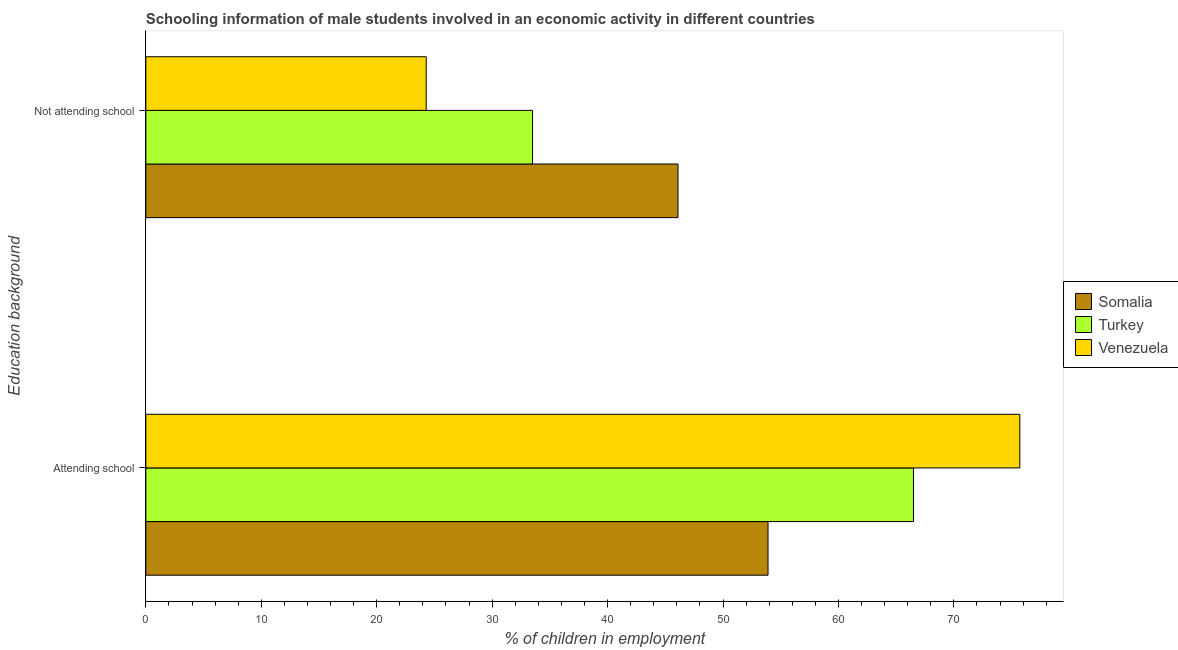How many different coloured bars are there?
Your answer should be compact. 3. How many groups of bars are there?
Your answer should be compact. 2. Are the number of bars on each tick of the Y-axis equal?
Your answer should be very brief. Yes. How many bars are there on the 1st tick from the top?
Your response must be concise. 3. What is the label of the 1st group of bars from the top?
Ensure brevity in your answer.  Not attending school. What is the percentage of employed males who are attending school in Somalia?
Provide a short and direct response. 53.9. Across all countries, what is the maximum percentage of employed males who are not attending school?
Give a very brief answer. 46.1. Across all countries, what is the minimum percentage of employed males who are not attending school?
Your answer should be compact. 24.29. In which country was the percentage of employed males who are not attending school maximum?
Make the answer very short. Somalia. In which country was the percentage of employed males who are not attending school minimum?
Make the answer very short. Venezuela. What is the total percentage of employed males who are not attending school in the graph?
Provide a short and direct response. 103.89. What is the difference between the percentage of employed males who are not attending school in Somalia and that in Turkey?
Your answer should be very brief. 12.6. What is the difference between the percentage of employed males who are not attending school in Somalia and the percentage of employed males who are attending school in Turkey?
Make the answer very short. -20.4. What is the average percentage of employed males who are attending school per country?
Your answer should be compact. 65.37. What is the difference between the percentage of employed males who are attending school and percentage of employed males who are not attending school in Venezuela?
Your answer should be very brief. 51.43. In how many countries, is the percentage of employed males who are not attending school greater than 52 %?
Offer a terse response. 0. What is the ratio of the percentage of employed males who are attending school in Somalia to that in Turkey?
Give a very brief answer. 0.81. Is the percentage of employed males who are attending school in Venezuela less than that in Somalia?
Give a very brief answer. No. What does the 3rd bar from the bottom in Attending school represents?
Provide a short and direct response. Venezuela. How many bars are there?
Provide a succinct answer. 6. How many countries are there in the graph?
Offer a terse response. 3. What is the difference between two consecutive major ticks on the X-axis?
Offer a terse response. 10. Are the values on the major ticks of X-axis written in scientific E-notation?
Offer a very short reply. No. Does the graph contain any zero values?
Your answer should be compact. No. Where does the legend appear in the graph?
Your answer should be very brief. Center right. What is the title of the graph?
Your answer should be very brief. Schooling information of male students involved in an economic activity in different countries. What is the label or title of the X-axis?
Your answer should be compact. % of children in employment. What is the label or title of the Y-axis?
Offer a terse response. Education background. What is the % of children in employment of Somalia in Attending school?
Make the answer very short. 53.9. What is the % of children in employment in Turkey in Attending school?
Offer a very short reply. 66.5. What is the % of children in employment of Venezuela in Attending school?
Offer a terse response. 75.71. What is the % of children in employment of Somalia in Not attending school?
Ensure brevity in your answer.  46.1. What is the % of children in employment in Turkey in Not attending school?
Make the answer very short. 33.5. What is the % of children in employment of Venezuela in Not attending school?
Provide a short and direct response. 24.29. Across all Education background, what is the maximum % of children in employment of Somalia?
Give a very brief answer. 53.9. Across all Education background, what is the maximum % of children in employment of Turkey?
Keep it short and to the point. 66.5. Across all Education background, what is the maximum % of children in employment of Venezuela?
Your answer should be compact. 75.71. Across all Education background, what is the minimum % of children in employment in Somalia?
Provide a short and direct response. 46.1. Across all Education background, what is the minimum % of children in employment of Turkey?
Give a very brief answer. 33.5. Across all Education background, what is the minimum % of children in employment in Venezuela?
Offer a terse response. 24.29. What is the total % of children in employment of Somalia in the graph?
Offer a terse response. 100. What is the total % of children in employment of Venezuela in the graph?
Your answer should be very brief. 100. What is the difference between the % of children in employment of Turkey in Attending school and that in Not attending school?
Your answer should be compact. 33. What is the difference between the % of children in employment of Venezuela in Attending school and that in Not attending school?
Provide a succinct answer. 51.43. What is the difference between the % of children in employment of Somalia in Attending school and the % of children in employment of Turkey in Not attending school?
Your answer should be compact. 20.4. What is the difference between the % of children in employment in Somalia in Attending school and the % of children in employment in Venezuela in Not attending school?
Offer a very short reply. 29.61. What is the difference between the % of children in employment of Turkey in Attending school and the % of children in employment of Venezuela in Not attending school?
Offer a very short reply. 42.21. What is the difference between the % of children in employment of Somalia and % of children in employment of Turkey in Attending school?
Your answer should be very brief. -12.6. What is the difference between the % of children in employment of Somalia and % of children in employment of Venezuela in Attending school?
Make the answer very short. -21.81. What is the difference between the % of children in employment of Turkey and % of children in employment of Venezuela in Attending school?
Your response must be concise. -9.21. What is the difference between the % of children in employment of Somalia and % of children in employment of Turkey in Not attending school?
Keep it short and to the point. 12.6. What is the difference between the % of children in employment of Somalia and % of children in employment of Venezuela in Not attending school?
Ensure brevity in your answer.  21.81. What is the difference between the % of children in employment in Turkey and % of children in employment in Venezuela in Not attending school?
Offer a very short reply. 9.21. What is the ratio of the % of children in employment in Somalia in Attending school to that in Not attending school?
Ensure brevity in your answer.  1.17. What is the ratio of the % of children in employment of Turkey in Attending school to that in Not attending school?
Give a very brief answer. 1.99. What is the ratio of the % of children in employment in Venezuela in Attending school to that in Not attending school?
Provide a short and direct response. 3.12. What is the difference between the highest and the second highest % of children in employment in Somalia?
Provide a short and direct response. 7.8. What is the difference between the highest and the second highest % of children in employment of Turkey?
Keep it short and to the point. 33. What is the difference between the highest and the second highest % of children in employment in Venezuela?
Give a very brief answer. 51.43. What is the difference between the highest and the lowest % of children in employment in Turkey?
Provide a short and direct response. 33. What is the difference between the highest and the lowest % of children in employment of Venezuela?
Make the answer very short. 51.43. 